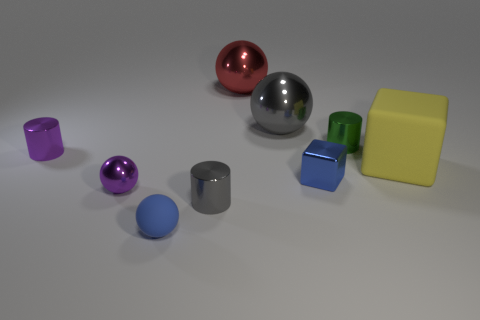Which object stands out the most to you and why? The large silver sphere stands out due to its size and central placement, drawing attention as it reflects more light and details of its surroundings compared to the other objects. Can you speculate on the purpose of this arrangement? The purpose of such an arrangement could be artistic or functional. Artistically, it creates an aesthetic of simplicity and variety, and functionally, it may be arranged for a visual demonstration, such as a physics experiment on light and reflections or for a modeling portfolio. 